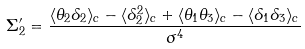<formula> <loc_0><loc_0><loc_500><loc_500>\Sigma _ { 2 } ^ { \prime } = \frac { \langle \theta _ { 2 } \delta _ { 2 } \rangle _ { c } - \langle \delta _ { 2 } ^ { 2 } \rangle _ { c } + \langle \theta _ { 1 } \theta _ { 3 } \rangle _ { c } - \langle \delta _ { 1 } \delta _ { 3 } \rangle _ { c } } { \sigma ^ { 4 } }</formula> 